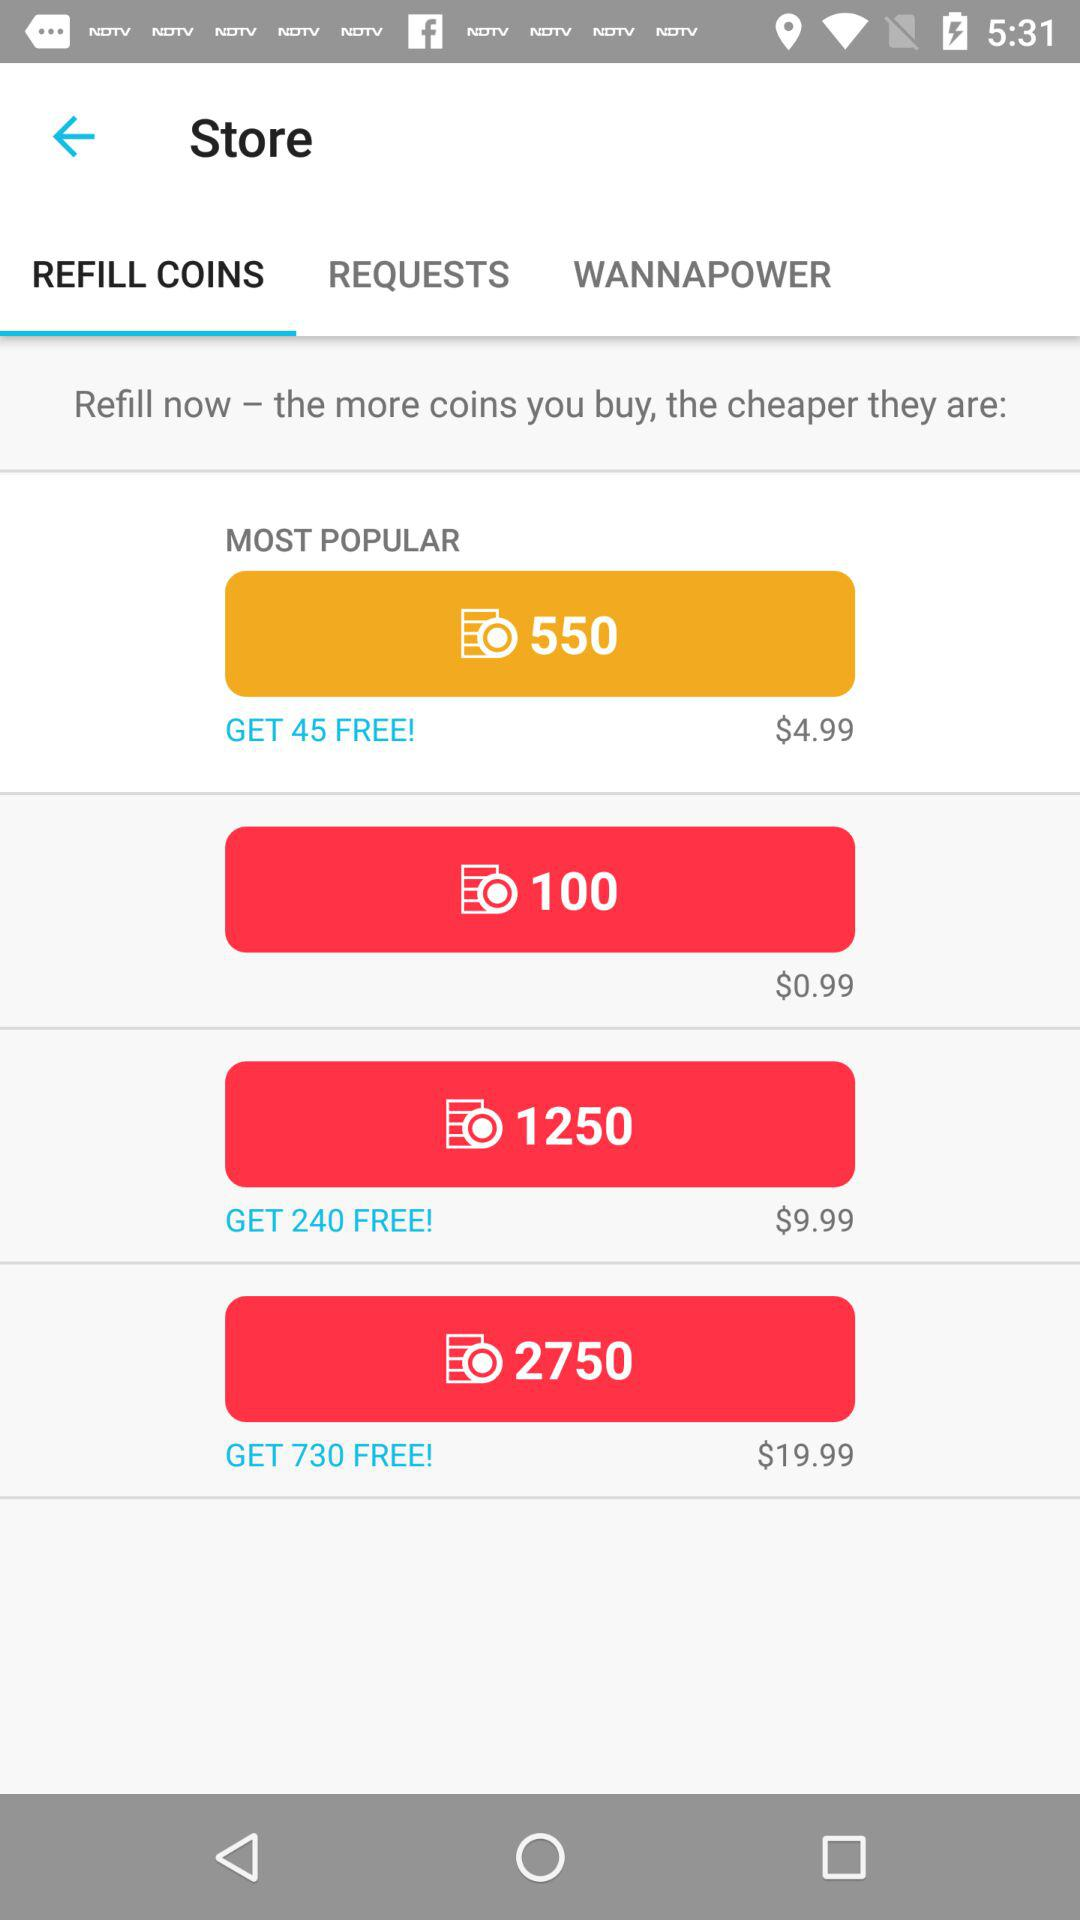Which tab has been selected? The tab that has been selected is "REFILL COINS". 